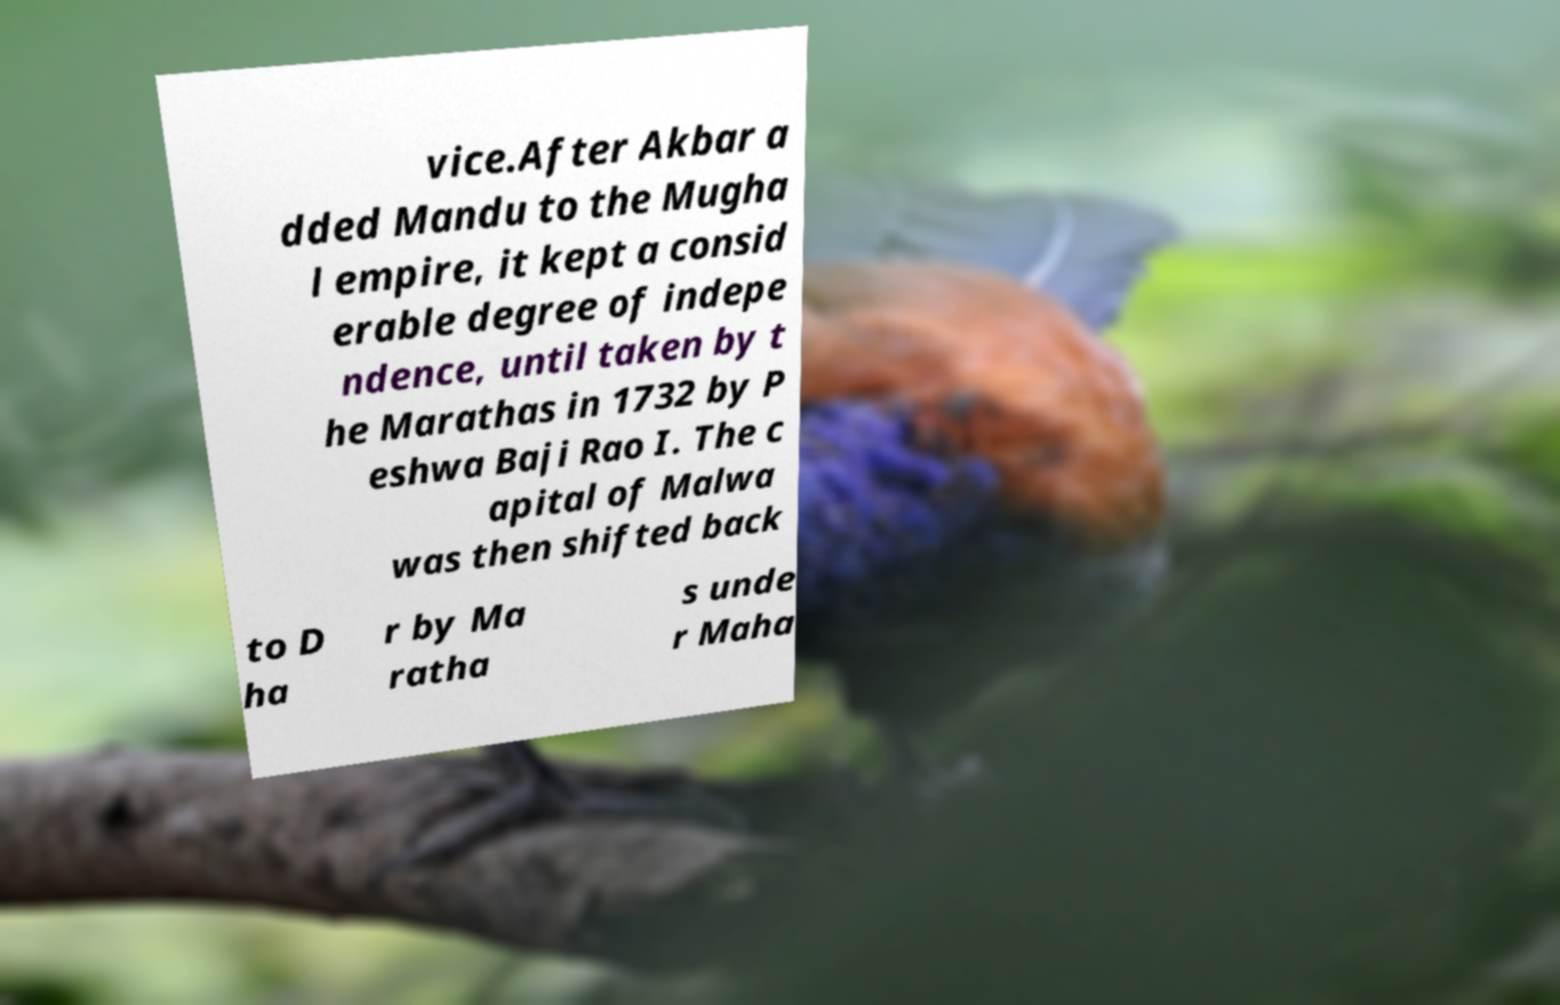Could you assist in decoding the text presented in this image and type it out clearly? vice.After Akbar a dded Mandu to the Mugha l empire, it kept a consid erable degree of indepe ndence, until taken by t he Marathas in 1732 by P eshwa Baji Rao I. The c apital of Malwa was then shifted back to D ha r by Ma ratha s unde r Maha 